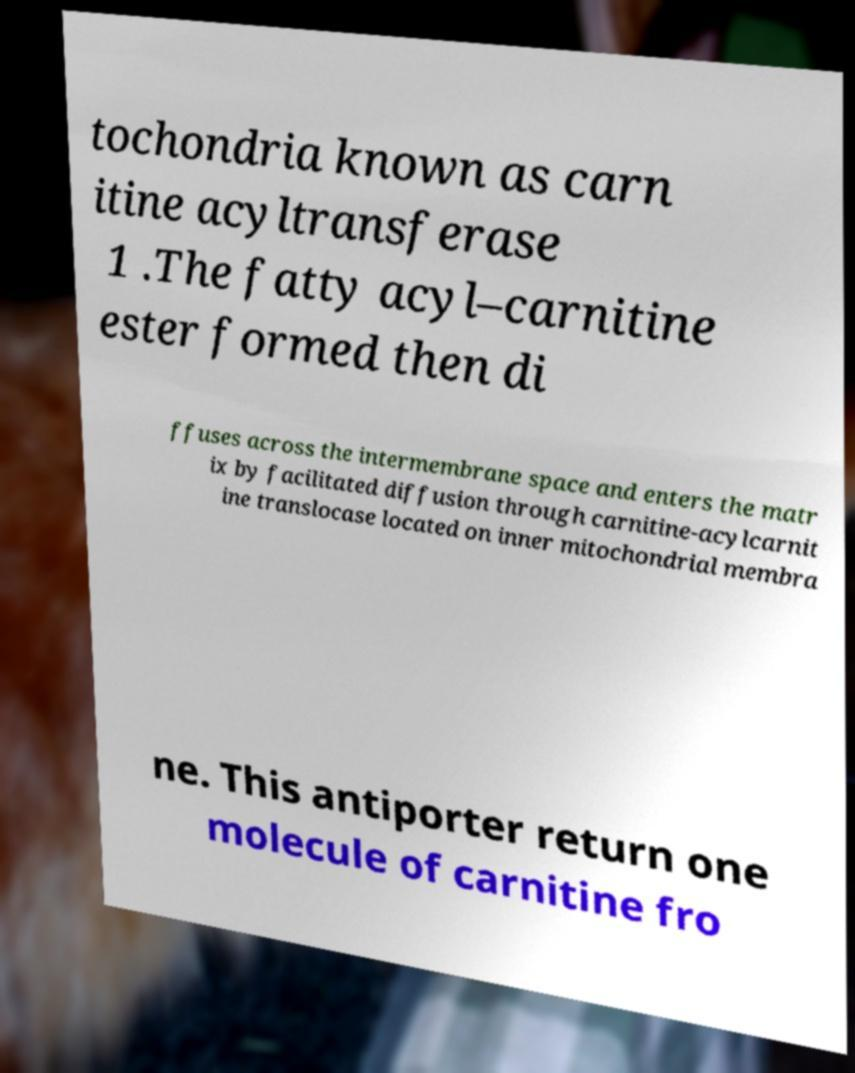Please identify and transcribe the text found in this image. tochondria known as carn itine acyltransferase 1 .The fatty acyl–carnitine ester formed then di ffuses across the intermembrane space and enters the matr ix by facilitated diffusion through carnitine-acylcarnit ine translocase located on inner mitochondrial membra ne. This antiporter return one molecule of carnitine fro 